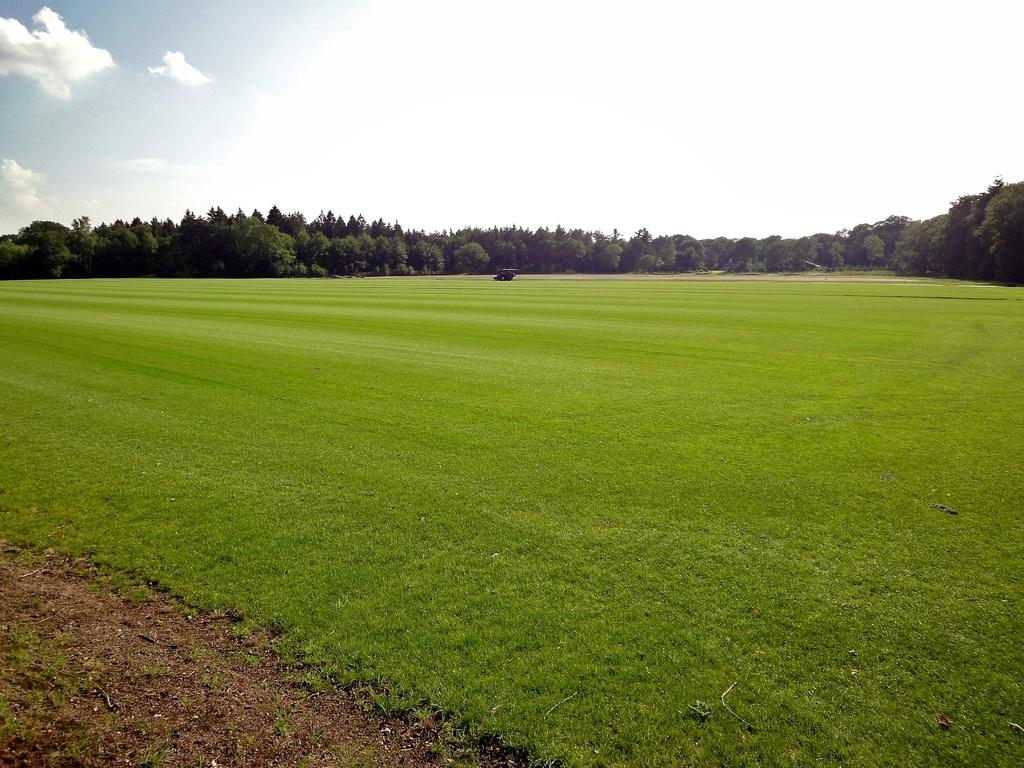What type of terrain is visible in the front of the image? There is a grassland in the front of the image. What can be seen in the background of the image? Trees are present in the background of the image. What part of the natural environment is visible in the image? The sky is visible in the image. What is the condition of the sky in the image? Clouds are present in the sky. How many toes are visible on the grassland in the image? There are no toes present in the image; it features a grassland and other natural elements. 